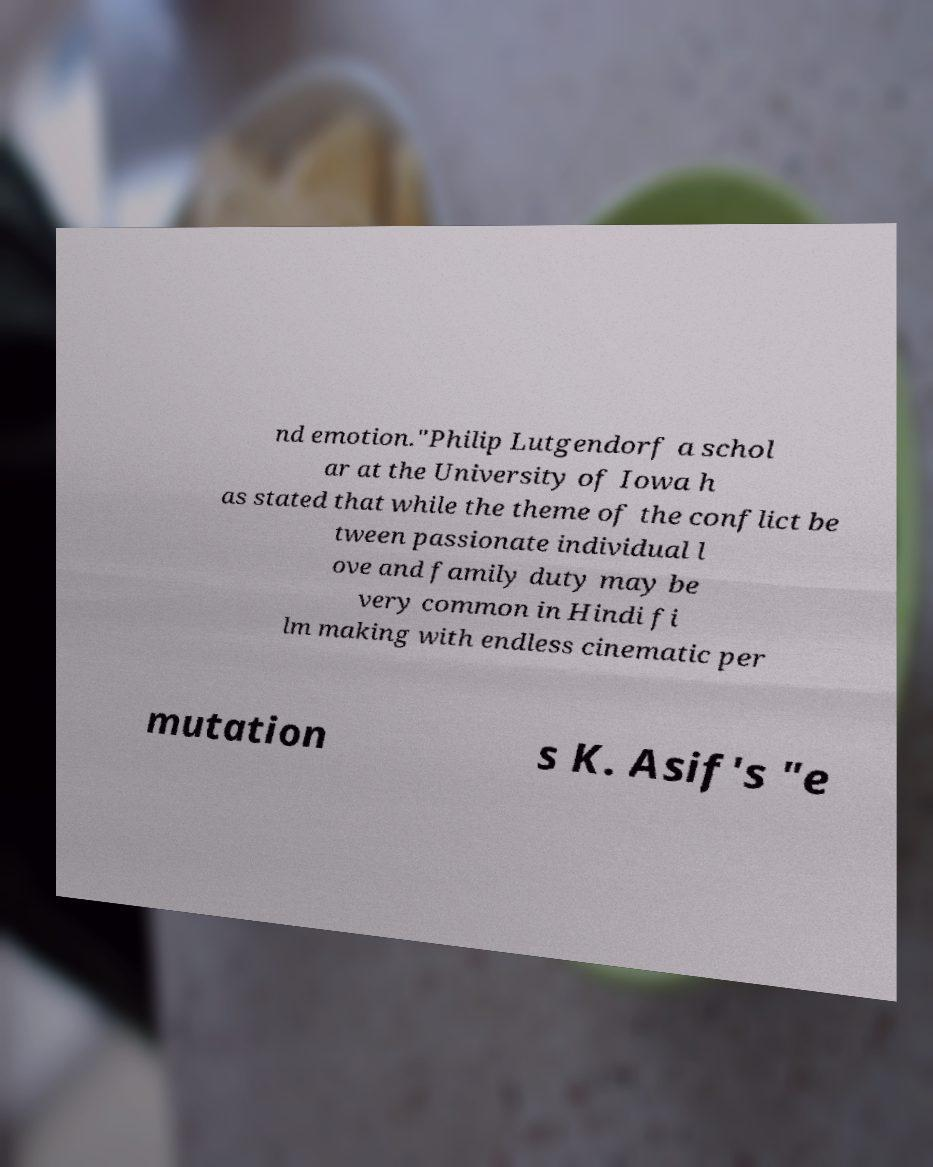There's text embedded in this image that I need extracted. Can you transcribe it verbatim? nd emotion."Philip Lutgendorf a schol ar at the University of Iowa h as stated that while the theme of the conflict be tween passionate individual l ove and family duty may be very common in Hindi fi lm making with endless cinematic per mutation s K. Asif's "e 